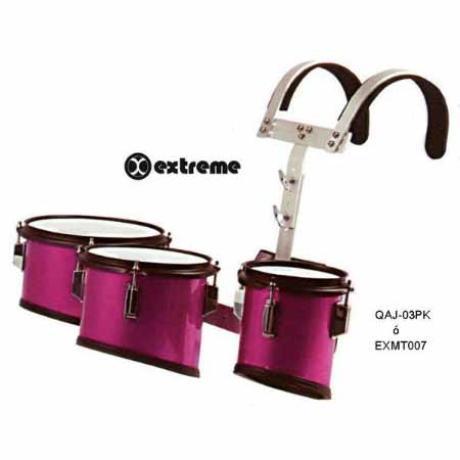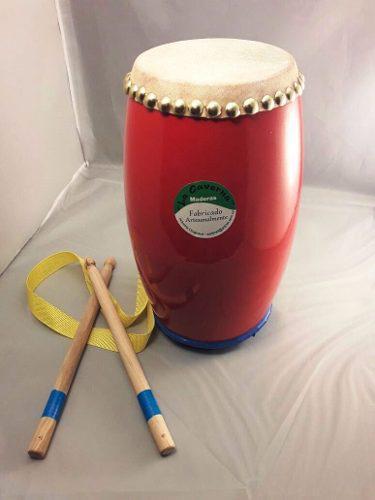The first image is the image on the left, the second image is the image on the right. Considering the images on both sides, is "The left image shows three pedestal-shaped drums with wood-grain exteriors, and the right image shows at least three white drums with black rims." valid? Answer yes or no. No. The first image is the image on the left, the second image is the image on the right. For the images displayed, is the sentence "There are three bongo drums." factually correct? Answer yes or no. No. 